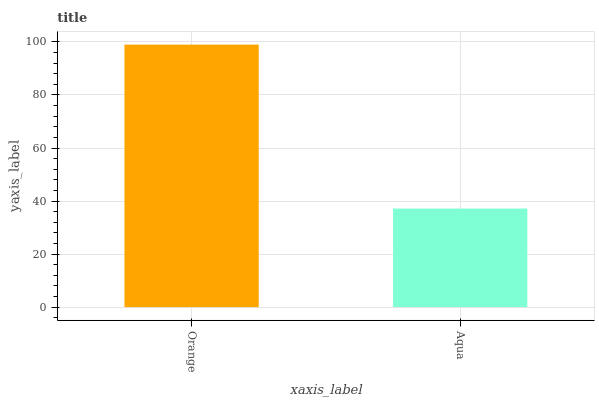Is Aqua the minimum?
Answer yes or no. Yes. Is Orange the maximum?
Answer yes or no. Yes. Is Aqua the maximum?
Answer yes or no. No. Is Orange greater than Aqua?
Answer yes or no. Yes. Is Aqua less than Orange?
Answer yes or no. Yes. Is Aqua greater than Orange?
Answer yes or no. No. Is Orange less than Aqua?
Answer yes or no. No. Is Orange the high median?
Answer yes or no. Yes. Is Aqua the low median?
Answer yes or no. Yes. Is Aqua the high median?
Answer yes or no. No. Is Orange the low median?
Answer yes or no. No. 